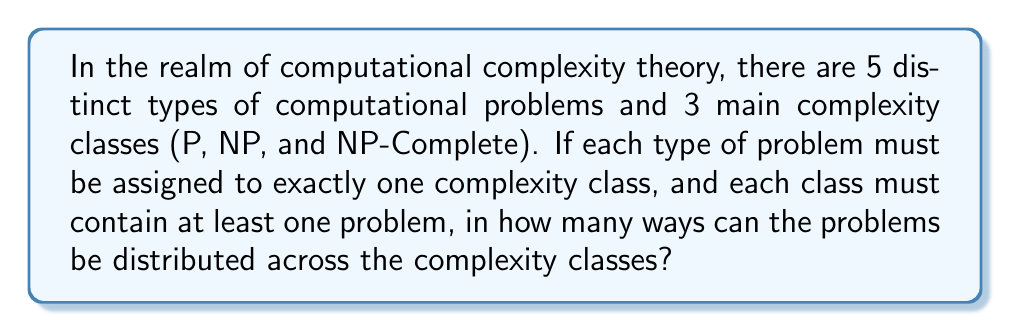Can you answer this question? Let's approach this step-by-step:

1) This is a problem of distributing distinguishable objects (the 5 types of problems) into distinguishable boxes (the 3 complexity classes) with restrictions.

2) We can use the concept of Stirling numbers of the second kind, denoted as $S(n,k)$, which counts the number of ways to partition n distinguishable objects into k non-empty subsets.

3) However, we need to consider all possible distributions where each class has at least one problem. This means we need to consider:
   - 3 classes with problems (5 problems distributed among 3 classes)
   - 2 classes with problems (5 problems distributed among 2 classes)
   - 1 class with problems (all 5 problems in 1 class) - but this doesn't meet our condition

4) For 3 classes:
   $S(5,3) = \frac{1}{6}(3^5 - 3 \cdot 2^5 + 3 \cdot 1^5) = 25$

5) For 2 classes:
   $S(5,2) = \frac{1}{2}(2^5 - 2 \cdot 1^5) = 15$

6) However, for the case of 2 classes, we need to multiply by 3C2 = 3, as we're choosing 2 out of 3 classes to fill.

7) Total number of ways = $25 + (15 \cdot 3) = 25 + 45 = 70$

Therefore, there are 70 ways to distribute the problems across the complexity classes.
Answer: 70 